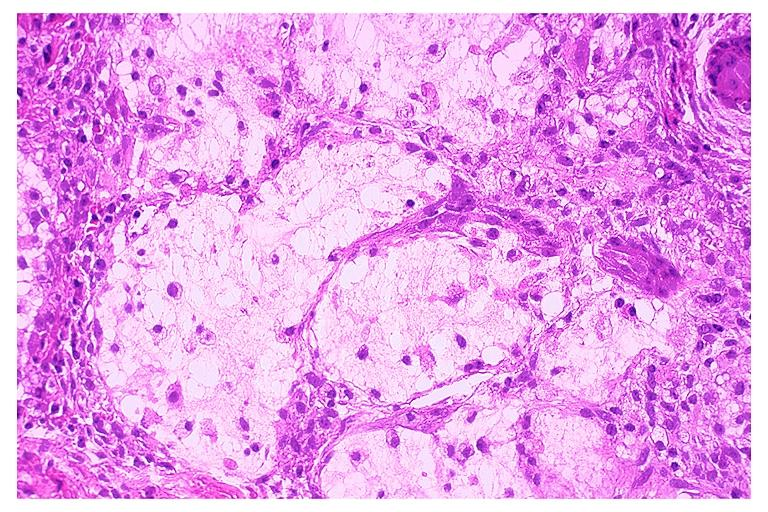does this image show necrotizing sialometaplasia?
Answer the question using a single word or phrase. Yes 